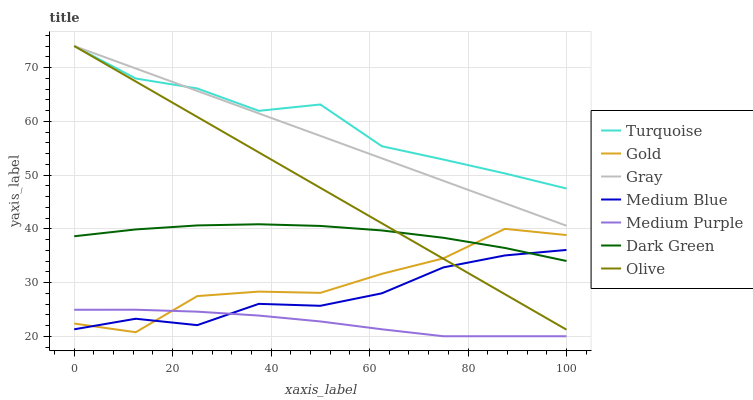Does Medium Purple have the minimum area under the curve?
Answer yes or no. Yes. Does Turquoise have the maximum area under the curve?
Answer yes or no. Yes. Does Gold have the minimum area under the curve?
Answer yes or no. No. Does Gold have the maximum area under the curve?
Answer yes or no. No. Is Gray the smoothest?
Answer yes or no. Yes. Is Gold the roughest?
Answer yes or no. Yes. Is Turquoise the smoothest?
Answer yes or no. No. Is Turquoise the roughest?
Answer yes or no. No. Does Medium Purple have the lowest value?
Answer yes or no. Yes. Does Gold have the lowest value?
Answer yes or no. No. Does Olive have the highest value?
Answer yes or no. Yes. Does Gold have the highest value?
Answer yes or no. No. Is Medium Purple less than Olive?
Answer yes or no. Yes. Is Olive greater than Medium Purple?
Answer yes or no. Yes. Does Medium Purple intersect Medium Blue?
Answer yes or no. Yes. Is Medium Purple less than Medium Blue?
Answer yes or no. No. Is Medium Purple greater than Medium Blue?
Answer yes or no. No. Does Medium Purple intersect Olive?
Answer yes or no. No. 